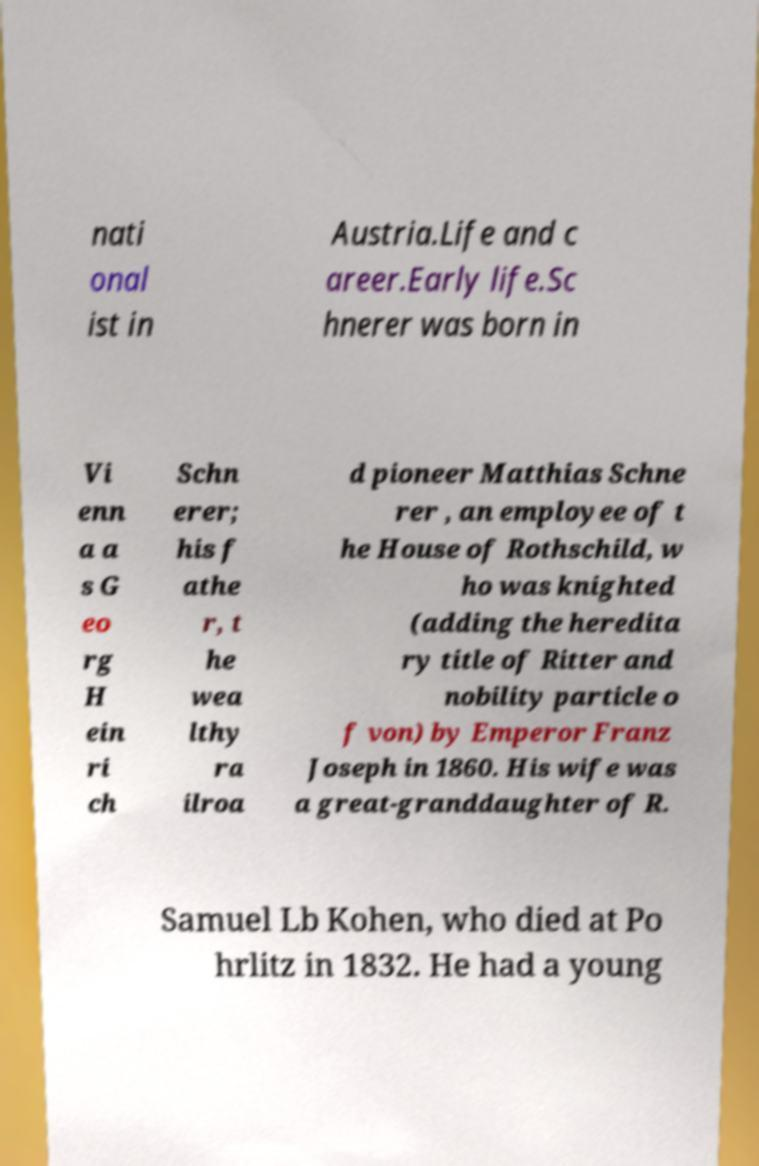Can you accurately transcribe the text from the provided image for me? nati onal ist in Austria.Life and c areer.Early life.Sc hnerer was born in Vi enn a a s G eo rg H ein ri ch Schn erer; his f athe r, t he wea lthy ra ilroa d pioneer Matthias Schne rer , an employee of t he House of Rothschild, w ho was knighted (adding the heredita ry title of Ritter and nobility particle o f von) by Emperor Franz Joseph in 1860. His wife was a great-granddaughter of R. Samuel Lb Kohen, who died at Po hrlitz in 1832. He had a young 